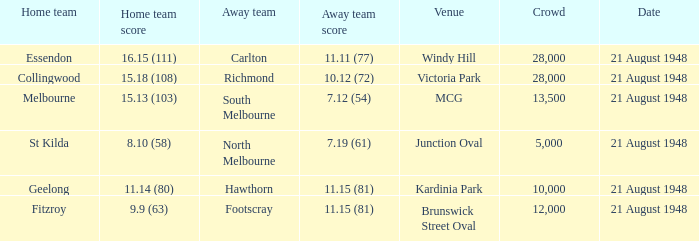When the venue is victoria park, what's the largest Crowd that attended? 28000.0. 